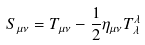Convert formula to latex. <formula><loc_0><loc_0><loc_500><loc_500>S _ { \mu \nu } = T _ { \mu \nu } - \frac { 1 } { 2 } \eta _ { \mu \nu } T _ { \lambda } ^ { \lambda }</formula> 